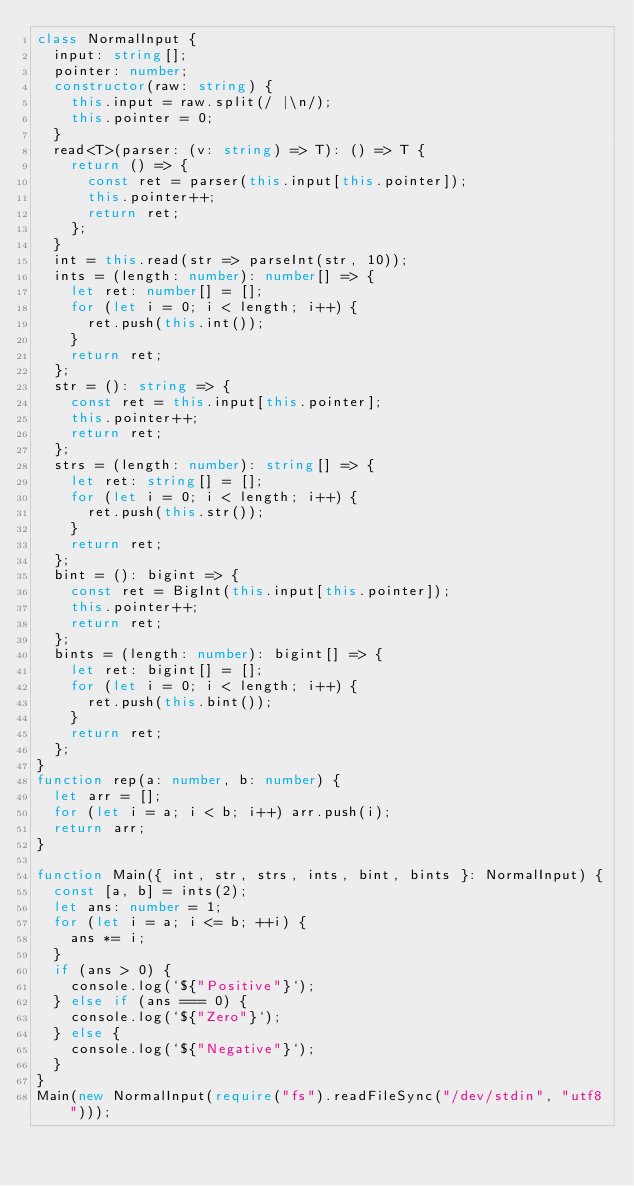Convert code to text. <code><loc_0><loc_0><loc_500><loc_500><_TypeScript_>class NormalInput {
  input: string[];
  pointer: number;
  constructor(raw: string) {
    this.input = raw.split(/ |\n/);
    this.pointer = 0;
  }
  read<T>(parser: (v: string) => T): () => T {
    return () => {
      const ret = parser(this.input[this.pointer]);
      this.pointer++;
      return ret;
    };
  }
  int = this.read(str => parseInt(str, 10));
  ints = (length: number): number[] => {
    let ret: number[] = [];
    for (let i = 0; i < length; i++) {
      ret.push(this.int());
    }
    return ret;
  };
  str = (): string => {
    const ret = this.input[this.pointer];
    this.pointer++;
    return ret;
  };
  strs = (length: number): string[] => {
    let ret: string[] = [];
    for (let i = 0; i < length; i++) {
      ret.push(this.str());
    }
    return ret;
  };
  bint = (): bigint => {
    const ret = BigInt(this.input[this.pointer]);
    this.pointer++;
    return ret;
  };
  bints = (length: number): bigint[] => {
    let ret: bigint[] = [];
    for (let i = 0; i < length; i++) {
      ret.push(this.bint());
    }
    return ret;
  };
}
function rep(a: number, b: number) {
  let arr = [];
  for (let i = a; i < b; i++) arr.push(i);
  return arr;
}

function Main({ int, str, strs, ints, bint, bints }: NormalInput) {
  const [a, b] = ints(2);
  let ans: number = 1;
  for (let i = a; i <= b; ++i) {
    ans *= i;
  }
  if (ans > 0) {
    console.log(`${"Positive"}`);
  } else if (ans === 0) {
    console.log(`${"Zero"}`);
  } else {
    console.log(`${"Negative"}`);
  }
}
Main(new NormalInput(require("fs").readFileSync("/dev/stdin", "utf8")));
</code> 